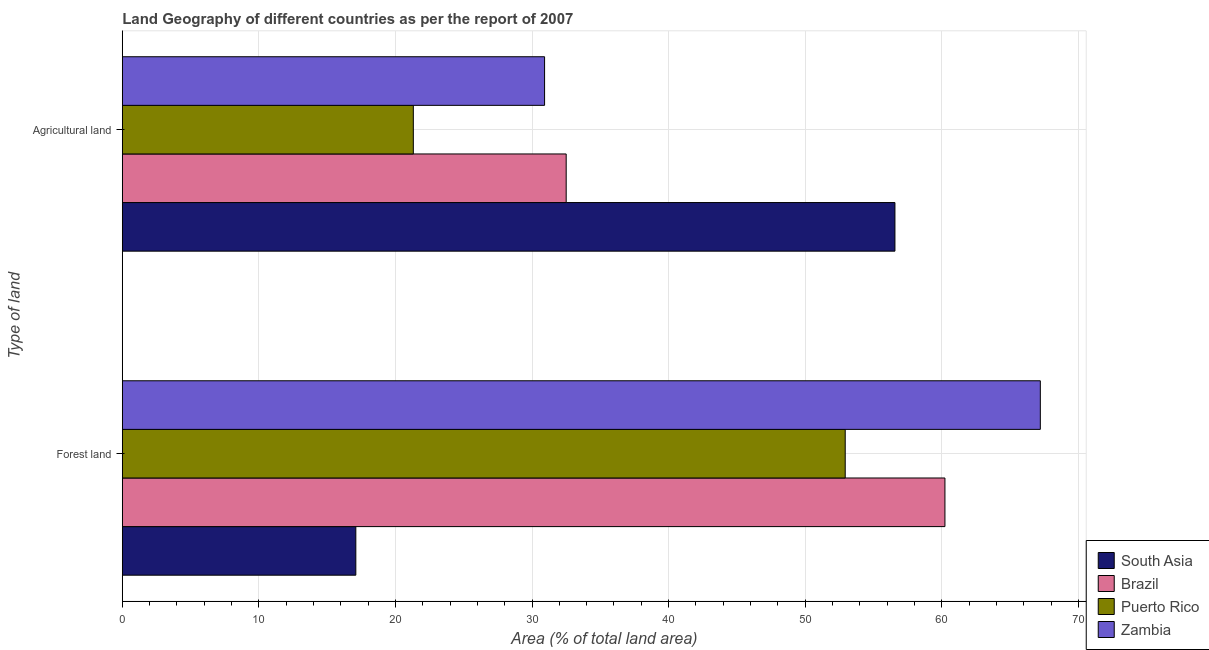Are the number of bars per tick equal to the number of legend labels?
Provide a succinct answer. Yes. Are the number of bars on each tick of the Y-axis equal?
Make the answer very short. Yes. What is the label of the 1st group of bars from the top?
Offer a terse response. Agricultural land. What is the percentage of land area under forests in Brazil?
Keep it short and to the point. 60.23. Across all countries, what is the maximum percentage of land area under forests?
Provide a short and direct response. 67.22. Across all countries, what is the minimum percentage of land area under agriculture?
Make the answer very short. 21.31. In which country was the percentage of land area under agriculture minimum?
Give a very brief answer. Puerto Rico. What is the total percentage of land area under agriculture in the graph?
Make the answer very short. 141.3. What is the difference between the percentage of land area under forests in Puerto Rico and that in South Asia?
Keep it short and to the point. 35.83. What is the difference between the percentage of land area under agriculture in Zambia and the percentage of land area under forests in South Asia?
Keep it short and to the point. 13.82. What is the average percentage of land area under agriculture per country?
Give a very brief answer. 35.32. What is the difference between the percentage of land area under agriculture and percentage of land area under forests in Puerto Rico?
Provide a succinct answer. -31.62. In how many countries, is the percentage of land area under forests greater than 38 %?
Your response must be concise. 3. What is the ratio of the percentage of land area under agriculture in Puerto Rico to that in South Asia?
Make the answer very short. 0.38. What does the 4th bar from the top in Forest land represents?
Ensure brevity in your answer.  South Asia. What does the 2nd bar from the bottom in Forest land represents?
Provide a succinct answer. Brazil. Are the values on the major ticks of X-axis written in scientific E-notation?
Give a very brief answer. No. Does the graph contain any zero values?
Your response must be concise. No. How many legend labels are there?
Give a very brief answer. 4. What is the title of the graph?
Ensure brevity in your answer.  Land Geography of different countries as per the report of 2007. What is the label or title of the X-axis?
Your answer should be very brief. Area (% of total land area). What is the label or title of the Y-axis?
Your answer should be compact. Type of land. What is the Area (% of total land area) in South Asia in Forest land?
Your response must be concise. 17.1. What is the Area (% of total land area) of Brazil in Forest land?
Offer a terse response. 60.23. What is the Area (% of total land area) of Puerto Rico in Forest land?
Give a very brief answer. 52.93. What is the Area (% of total land area) of Zambia in Forest land?
Offer a terse response. 67.22. What is the Area (% of total land area) of South Asia in Agricultural land?
Provide a succinct answer. 56.57. What is the Area (% of total land area) of Brazil in Agricultural land?
Give a very brief answer. 32.5. What is the Area (% of total land area) in Puerto Rico in Agricultural land?
Offer a very short reply. 21.31. What is the Area (% of total land area) of Zambia in Agricultural land?
Your response must be concise. 30.92. Across all Type of land, what is the maximum Area (% of total land area) of South Asia?
Ensure brevity in your answer.  56.57. Across all Type of land, what is the maximum Area (% of total land area) of Brazil?
Keep it short and to the point. 60.23. Across all Type of land, what is the maximum Area (% of total land area) of Puerto Rico?
Your answer should be compact. 52.93. Across all Type of land, what is the maximum Area (% of total land area) in Zambia?
Provide a short and direct response. 67.22. Across all Type of land, what is the minimum Area (% of total land area) of South Asia?
Make the answer very short. 17.1. Across all Type of land, what is the minimum Area (% of total land area) in Brazil?
Offer a very short reply. 32.5. Across all Type of land, what is the minimum Area (% of total land area) of Puerto Rico?
Make the answer very short. 21.31. Across all Type of land, what is the minimum Area (% of total land area) of Zambia?
Ensure brevity in your answer.  30.92. What is the total Area (% of total land area) of South Asia in the graph?
Offer a very short reply. 73.67. What is the total Area (% of total land area) of Brazil in the graph?
Ensure brevity in your answer.  92.73. What is the total Area (% of total land area) in Puerto Rico in the graph?
Your answer should be very brief. 74.24. What is the total Area (% of total land area) of Zambia in the graph?
Make the answer very short. 98.13. What is the difference between the Area (% of total land area) of South Asia in Forest land and that in Agricultural land?
Offer a terse response. -39.47. What is the difference between the Area (% of total land area) in Brazil in Forest land and that in Agricultural land?
Provide a short and direct response. 27.73. What is the difference between the Area (% of total land area) in Puerto Rico in Forest land and that in Agricultural land?
Your response must be concise. 31.62. What is the difference between the Area (% of total land area) in Zambia in Forest land and that in Agricultural land?
Offer a very short reply. 36.3. What is the difference between the Area (% of total land area) in South Asia in Forest land and the Area (% of total land area) in Brazil in Agricultural land?
Offer a very short reply. -15.4. What is the difference between the Area (% of total land area) in South Asia in Forest land and the Area (% of total land area) in Puerto Rico in Agricultural land?
Make the answer very short. -4.21. What is the difference between the Area (% of total land area) in South Asia in Forest land and the Area (% of total land area) in Zambia in Agricultural land?
Provide a short and direct response. -13.82. What is the difference between the Area (% of total land area) in Brazil in Forest land and the Area (% of total land area) in Puerto Rico in Agricultural land?
Ensure brevity in your answer.  38.92. What is the difference between the Area (% of total land area) in Brazil in Forest land and the Area (% of total land area) in Zambia in Agricultural land?
Make the answer very short. 29.31. What is the difference between the Area (% of total land area) of Puerto Rico in Forest land and the Area (% of total land area) of Zambia in Agricultural land?
Keep it short and to the point. 22.01. What is the average Area (% of total land area) of South Asia per Type of land?
Offer a terse response. 36.83. What is the average Area (% of total land area) in Brazil per Type of land?
Keep it short and to the point. 46.37. What is the average Area (% of total land area) of Puerto Rico per Type of land?
Provide a succinct answer. 37.12. What is the average Area (% of total land area) of Zambia per Type of land?
Your answer should be very brief. 49.07. What is the difference between the Area (% of total land area) of South Asia and Area (% of total land area) of Brazil in Forest land?
Your response must be concise. -43.13. What is the difference between the Area (% of total land area) of South Asia and Area (% of total land area) of Puerto Rico in Forest land?
Provide a succinct answer. -35.83. What is the difference between the Area (% of total land area) in South Asia and Area (% of total land area) in Zambia in Forest land?
Your answer should be compact. -50.12. What is the difference between the Area (% of total land area) of Brazil and Area (% of total land area) of Puerto Rico in Forest land?
Offer a very short reply. 7.3. What is the difference between the Area (% of total land area) of Brazil and Area (% of total land area) of Zambia in Forest land?
Give a very brief answer. -6.98. What is the difference between the Area (% of total land area) of Puerto Rico and Area (% of total land area) of Zambia in Forest land?
Give a very brief answer. -14.29. What is the difference between the Area (% of total land area) of South Asia and Area (% of total land area) of Brazil in Agricultural land?
Provide a short and direct response. 24.07. What is the difference between the Area (% of total land area) of South Asia and Area (% of total land area) of Puerto Rico in Agricultural land?
Offer a very short reply. 35.26. What is the difference between the Area (% of total land area) in South Asia and Area (% of total land area) in Zambia in Agricultural land?
Offer a very short reply. 25.65. What is the difference between the Area (% of total land area) of Brazil and Area (% of total land area) of Puerto Rico in Agricultural land?
Make the answer very short. 11.19. What is the difference between the Area (% of total land area) in Brazil and Area (% of total land area) in Zambia in Agricultural land?
Ensure brevity in your answer.  1.58. What is the difference between the Area (% of total land area) in Puerto Rico and Area (% of total land area) in Zambia in Agricultural land?
Keep it short and to the point. -9.61. What is the ratio of the Area (% of total land area) of South Asia in Forest land to that in Agricultural land?
Your answer should be very brief. 0.3. What is the ratio of the Area (% of total land area) of Brazil in Forest land to that in Agricultural land?
Keep it short and to the point. 1.85. What is the ratio of the Area (% of total land area) in Puerto Rico in Forest land to that in Agricultural land?
Your response must be concise. 2.48. What is the ratio of the Area (% of total land area) in Zambia in Forest land to that in Agricultural land?
Your response must be concise. 2.17. What is the difference between the highest and the second highest Area (% of total land area) in South Asia?
Offer a very short reply. 39.47. What is the difference between the highest and the second highest Area (% of total land area) in Brazil?
Offer a terse response. 27.73. What is the difference between the highest and the second highest Area (% of total land area) of Puerto Rico?
Offer a very short reply. 31.62. What is the difference between the highest and the second highest Area (% of total land area) in Zambia?
Give a very brief answer. 36.3. What is the difference between the highest and the lowest Area (% of total land area) in South Asia?
Provide a succinct answer. 39.47. What is the difference between the highest and the lowest Area (% of total land area) in Brazil?
Provide a succinct answer. 27.73. What is the difference between the highest and the lowest Area (% of total land area) in Puerto Rico?
Make the answer very short. 31.62. What is the difference between the highest and the lowest Area (% of total land area) of Zambia?
Your response must be concise. 36.3. 